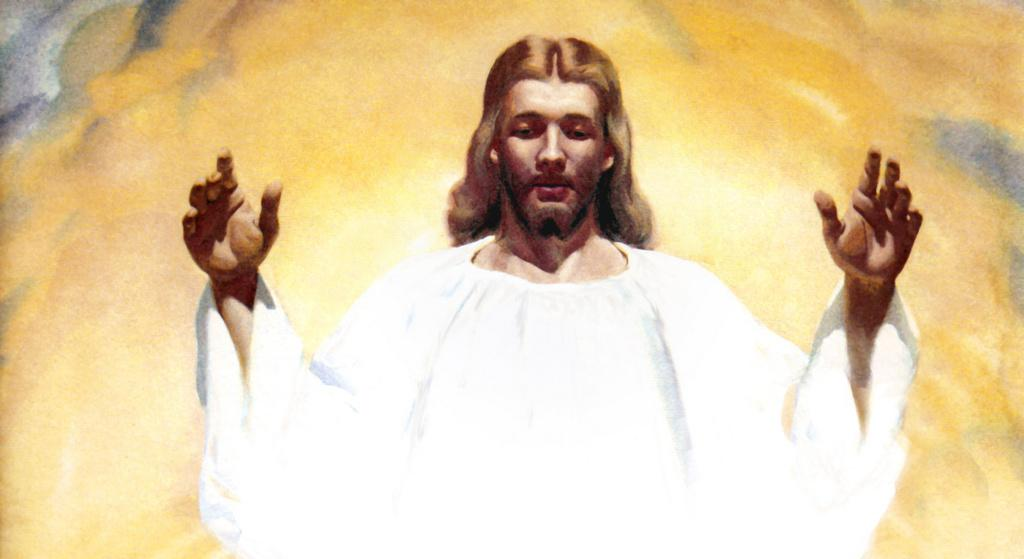What type of artwork is depicted in the image? The image is a painting. Can you describe the main subject of the painting? There is a person in the center of the painting. What color can be seen in the background of the painting? There is yellow color visible in the background of the painting. Is there a door visible in the painting? There is no mention of a door in the provided facts, so it cannot be determined if a door is present in the painting. 